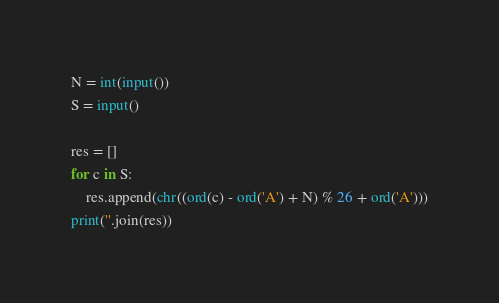Convert code to text. <code><loc_0><loc_0><loc_500><loc_500><_Python_>N = int(input())
S = input()

res = []
for c in S:
    res.append(chr((ord(c) - ord('A') + N) % 26 + ord('A')))
print(''.join(res))
</code> 